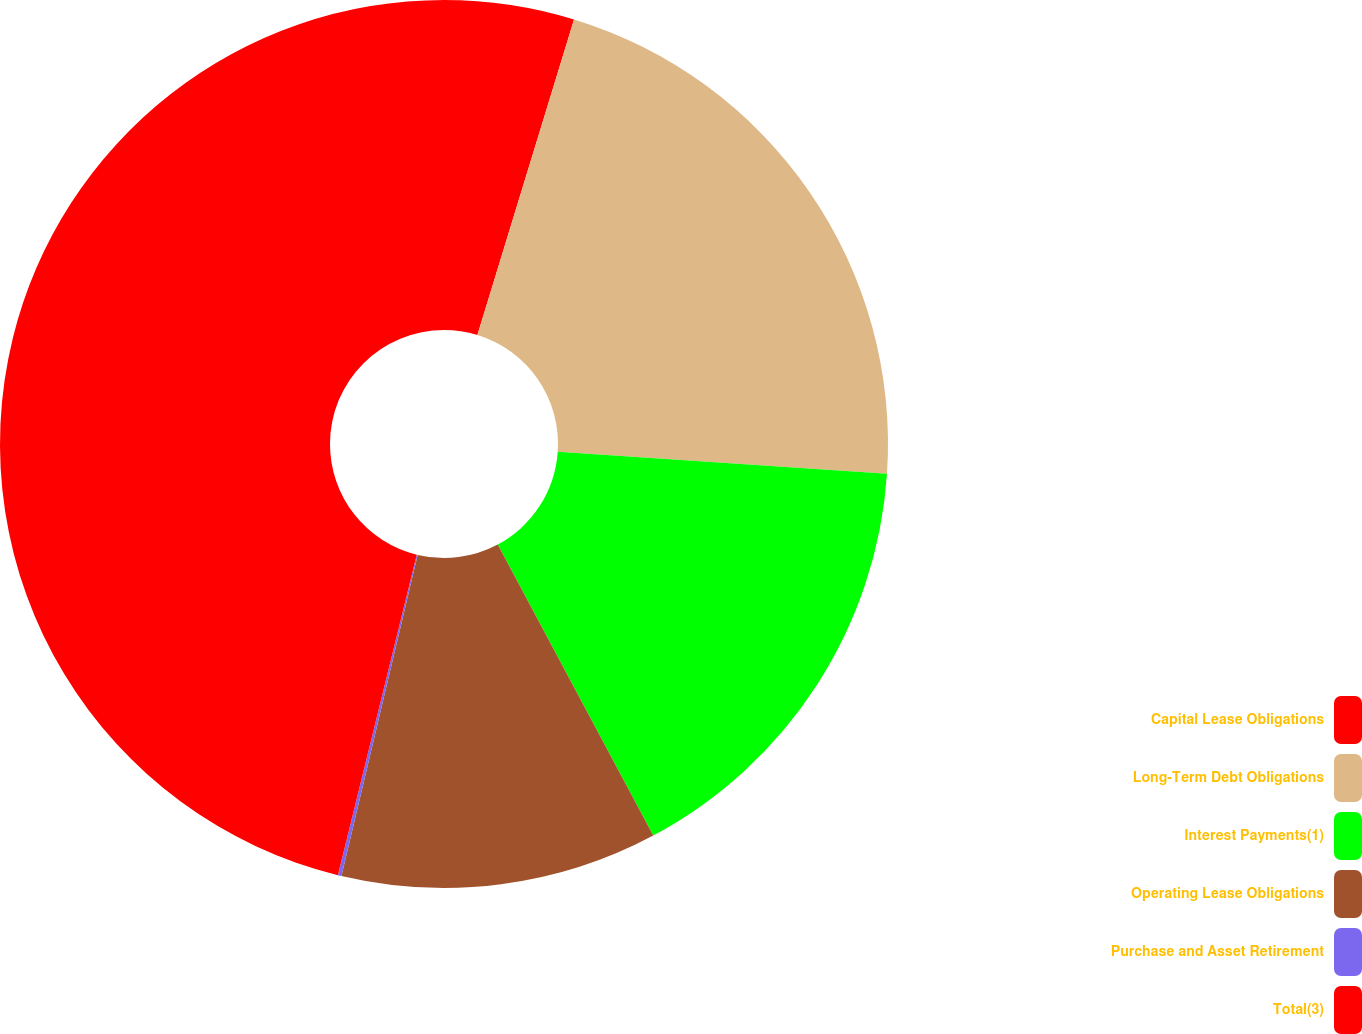<chart> <loc_0><loc_0><loc_500><loc_500><pie_chart><fcel>Capital Lease Obligations<fcel>Long-Term Debt Obligations<fcel>Interest Payments(1)<fcel>Operating Lease Obligations<fcel>Purchase and Asset Retirement<fcel>Total(3)<nl><fcel>4.73%<fcel>21.34%<fcel>16.12%<fcel>11.52%<fcel>0.13%<fcel>46.16%<nl></chart> 